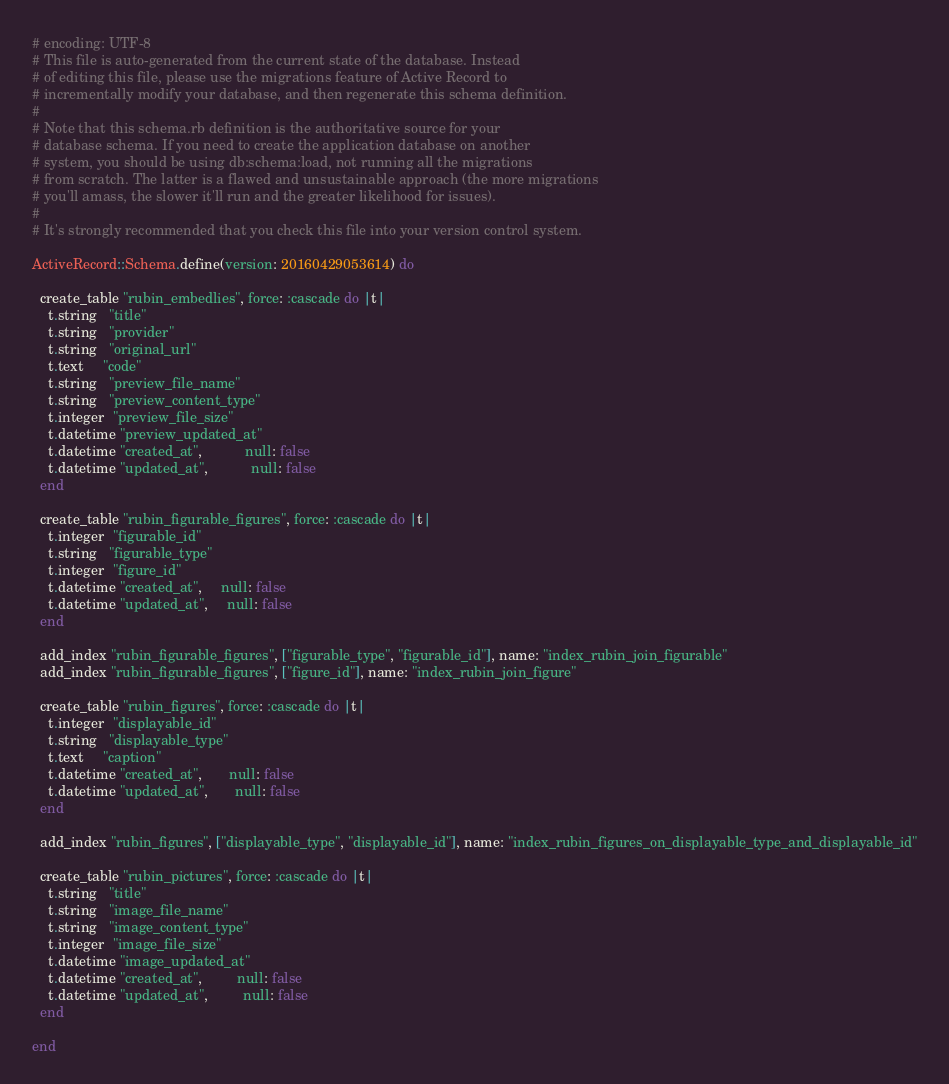<code> <loc_0><loc_0><loc_500><loc_500><_Ruby_># encoding: UTF-8
# This file is auto-generated from the current state of the database. Instead
# of editing this file, please use the migrations feature of Active Record to
# incrementally modify your database, and then regenerate this schema definition.
#
# Note that this schema.rb definition is the authoritative source for your
# database schema. If you need to create the application database on another
# system, you should be using db:schema:load, not running all the migrations
# from scratch. The latter is a flawed and unsustainable approach (the more migrations
# you'll amass, the slower it'll run and the greater likelihood for issues).
#
# It's strongly recommended that you check this file into your version control system.

ActiveRecord::Schema.define(version: 20160429053614) do

  create_table "rubin_embedlies", force: :cascade do |t|
    t.string   "title"
    t.string   "provider"
    t.string   "original_url"
    t.text     "code"
    t.string   "preview_file_name"
    t.string   "preview_content_type"
    t.integer  "preview_file_size"
    t.datetime "preview_updated_at"
    t.datetime "created_at",           null: false
    t.datetime "updated_at",           null: false
  end

  create_table "rubin_figurable_figures", force: :cascade do |t|
    t.integer  "figurable_id"
    t.string   "figurable_type"
    t.integer  "figure_id"
    t.datetime "created_at",     null: false
    t.datetime "updated_at",     null: false
  end

  add_index "rubin_figurable_figures", ["figurable_type", "figurable_id"], name: "index_rubin_join_figurable"
  add_index "rubin_figurable_figures", ["figure_id"], name: "index_rubin_join_figure"

  create_table "rubin_figures", force: :cascade do |t|
    t.integer  "displayable_id"
    t.string   "displayable_type"
    t.text     "caption"
    t.datetime "created_at",       null: false
    t.datetime "updated_at",       null: false
  end

  add_index "rubin_figures", ["displayable_type", "displayable_id"], name: "index_rubin_figures_on_displayable_type_and_displayable_id"

  create_table "rubin_pictures", force: :cascade do |t|
    t.string   "title"
    t.string   "image_file_name"
    t.string   "image_content_type"
    t.integer  "image_file_size"
    t.datetime "image_updated_at"
    t.datetime "created_at",         null: false
    t.datetime "updated_at",         null: false
  end

end
</code> 